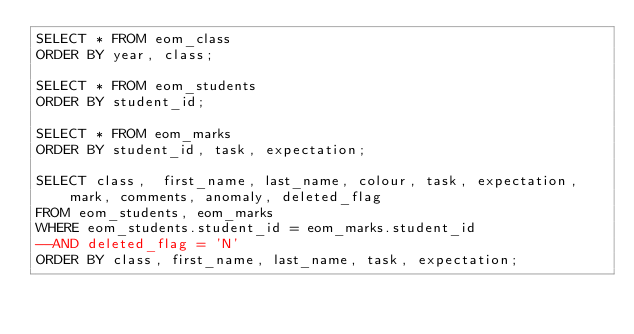Convert code to text. <code><loc_0><loc_0><loc_500><loc_500><_SQL_>SELECT * FROM eom_class 
ORDER BY year, class;

SELECT * FROM eom_students
ORDER BY student_id;

SELECT * FROM eom_marks
ORDER BY student_id, task, expectation;

SELECT class,  first_name, last_name, colour, task, expectation, mark, comments, anomaly, deleted_flag
FROM eom_students, eom_marks
WHERE eom_students.student_id = eom_marks.student_id
--AND deleted_flag = 'N'
ORDER BY class, first_name, last_name, task, expectation;</code> 